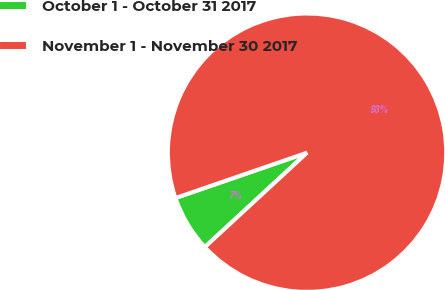Convert chart to OTSL. <chart><loc_0><loc_0><loc_500><loc_500><pie_chart><fcel>October 1 - October 31 2017<fcel>November 1 - November 30 2017<nl><fcel>6.59%<fcel>93.41%<nl></chart> 